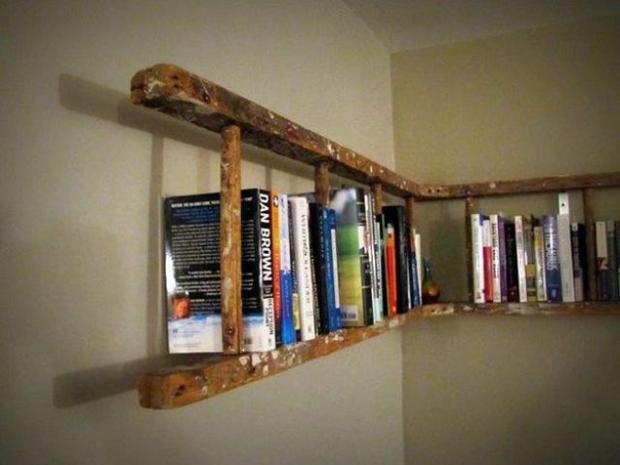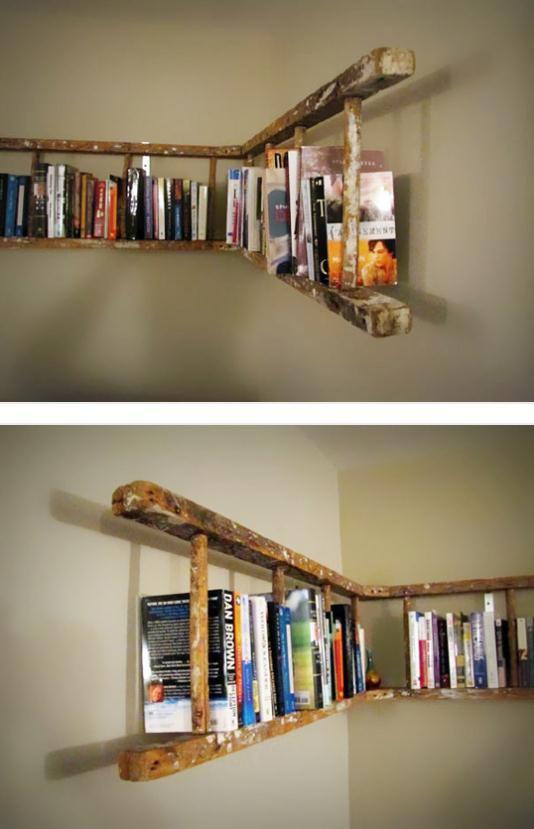The first image is the image on the left, the second image is the image on the right. Analyze the images presented: Is the assertion "The bookshelves in at least one image angle around the corner of room, so that they  extend outward on two walls." valid? Answer yes or no. Yes. The first image is the image on the left, the second image is the image on the right. Considering the images on both sides, is "Bookshelves are attached to the wall in a room;" valid? Answer yes or no. Yes. 